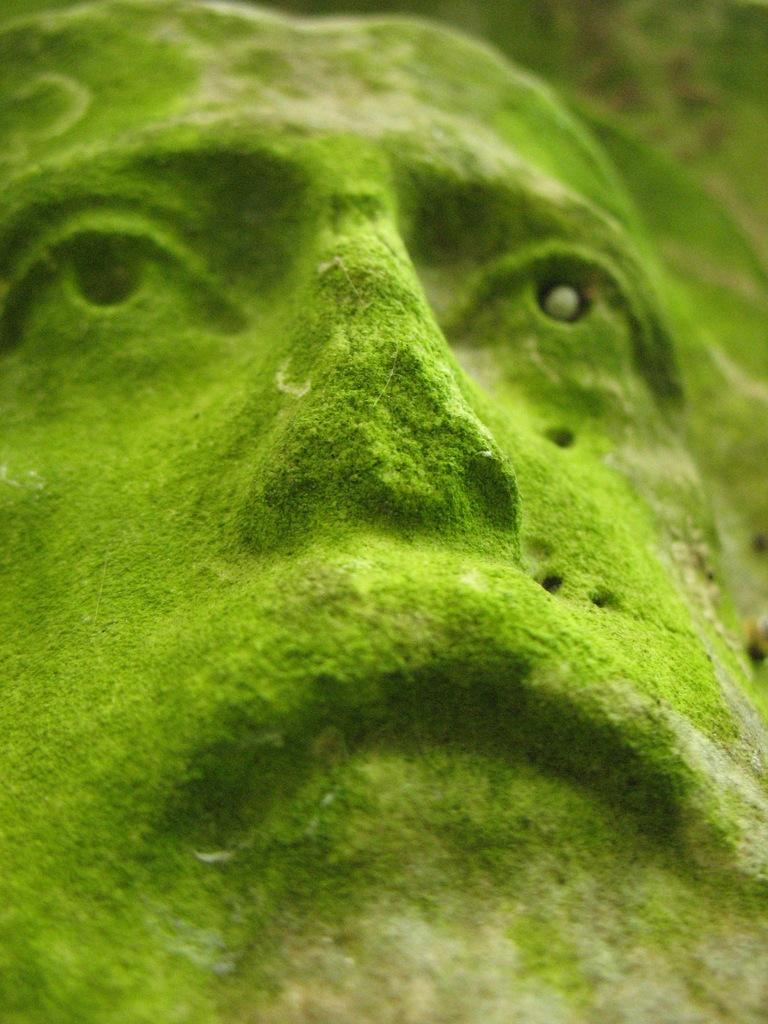What is the main subject of the image? The main subject of the image is a statue face. What type of iron is used to create the baby's crib in the image? There is no baby or crib present in the image; it only features a statue face. Additionally, the question about the type of iron is unrelated to the image and cannot be answered definitively. 